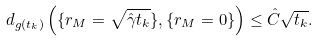Convert formula to latex. <formula><loc_0><loc_0><loc_500><loc_500>d _ { g ( t _ { k } ) } \left ( \{ r _ { M } = \sqrt { \hat { \gamma } t _ { k } } \} , \{ r _ { M } = 0 \} \right ) \leq \hat { C } \sqrt { t _ { k } } .</formula> 